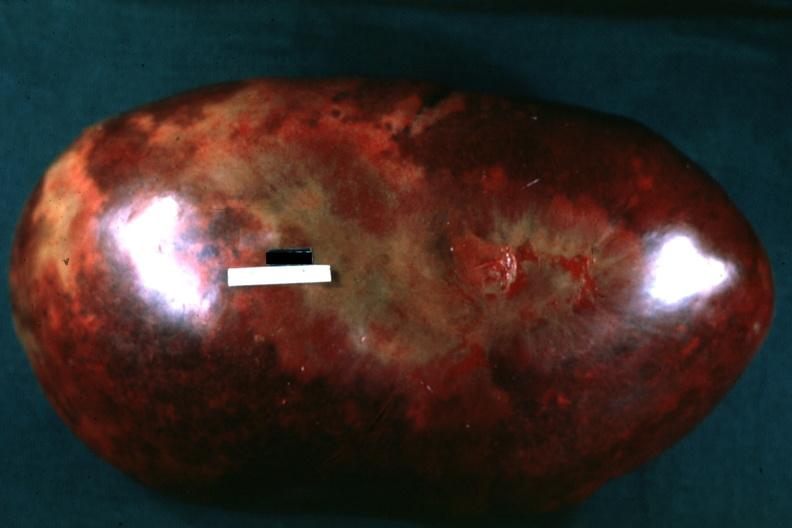what is present?
Answer the question using a single word or phrase. Hematologic 